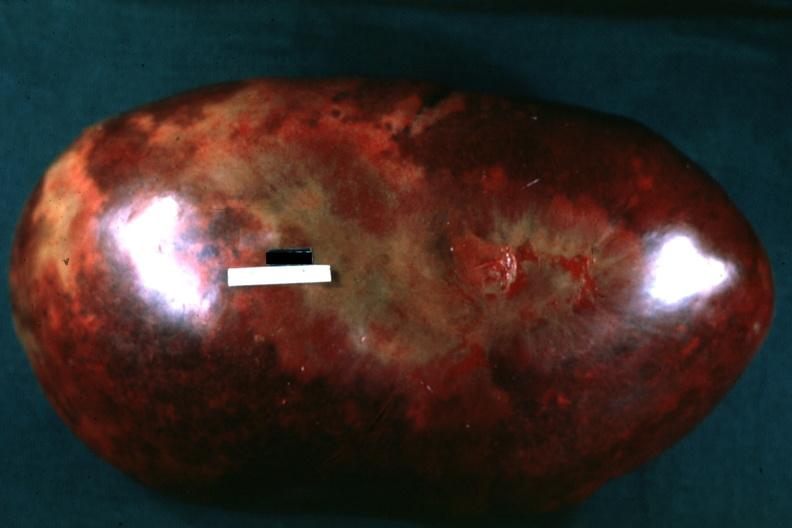what is present?
Answer the question using a single word or phrase. Hematologic 